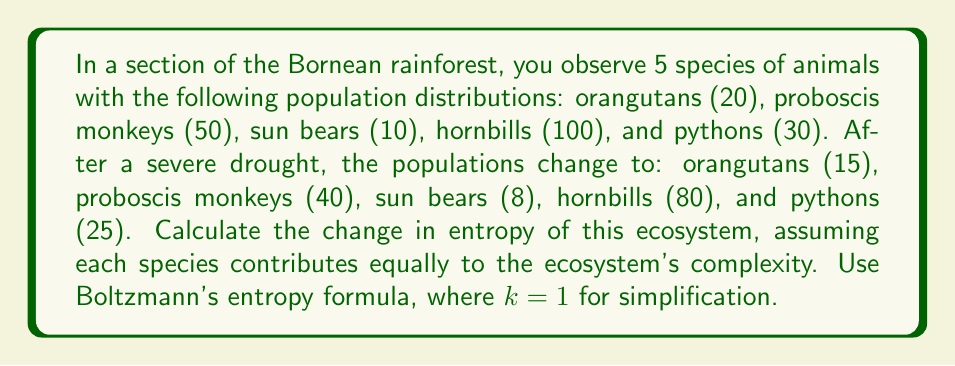Teach me how to tackle this problem. To calculate the change in entropy, we'll use Boltzmann's entropy formula: $S = k \ln W$, where $S$ is entropy, $k$ is Boltzmann's constant (set to 1 for simplification), and $W$ is the number of microstates.

1. Calculate total population before and after:
   Before: $20 + 50 + 10 + 100 + 30 = 210$
   After: $15 + 40 + 8 + 80 + 25 = 168$

2. Calculate probabilities for each species before:
   $p_1 = 20/210$, $p_2 = 50/210$, $p_3 = 10/210$, $p_4 = 100/210$, $p_5 = 30/210$

3. Calculate probabilities for each species after:
   $p_1' = 15/168$, $p_2' = 40/168$, $p_3' = 8/168$, $p_4' = 80/168$, $p_5' = 25/168$

4. Calculate entropy before:
   $S_1 = -1 \cdot (p_1 \ln p_1 + p_2 \ln p_2 + p_3 \ln p_3 + p_4 \ln p_4 + p_5 \ln p_5)$
   $S_1 = -1 \cdot (\frac{20}{210} \ln \frac{20}{210} + \frac{50}{210} \ln \frac{50}{210} + \frac{10}{210} \ln \frac{10}{210} + \frac{100}{210} \ln \frac{100}{210} + \frac{30}{210} \ln \frac{30}{210})$
   $S_1 \approx 1.4295$

5. Calculate entropy after:
   $S_2 = -1 \cdot (p_1' \ln p_1' + p_2' \ln p_2' + p_3' \ln p_3' + p_4' \ln p_4' + p_5' \ln p_5')$
   $S_2 = -1 \cdot (\frac{15}{168} \ln \frac{15}{168} + \frac{40}{168} \ln \frac{40}{168} + \frac{8}{168} \ln \frac{8}{168} + \frac{80}{168} \ln \frac{80}{168} + \frac{25}{168} \ln \frac{25}{168})$
   $S_2 \approx 1.4102$

6. Calculate change in entropy:
   $\Delta S = S_2 - S_1 \approx 1.4102 - 1.4295 \approx -0.0193$
Answer: $\Delta S \approx -0.0193$ 